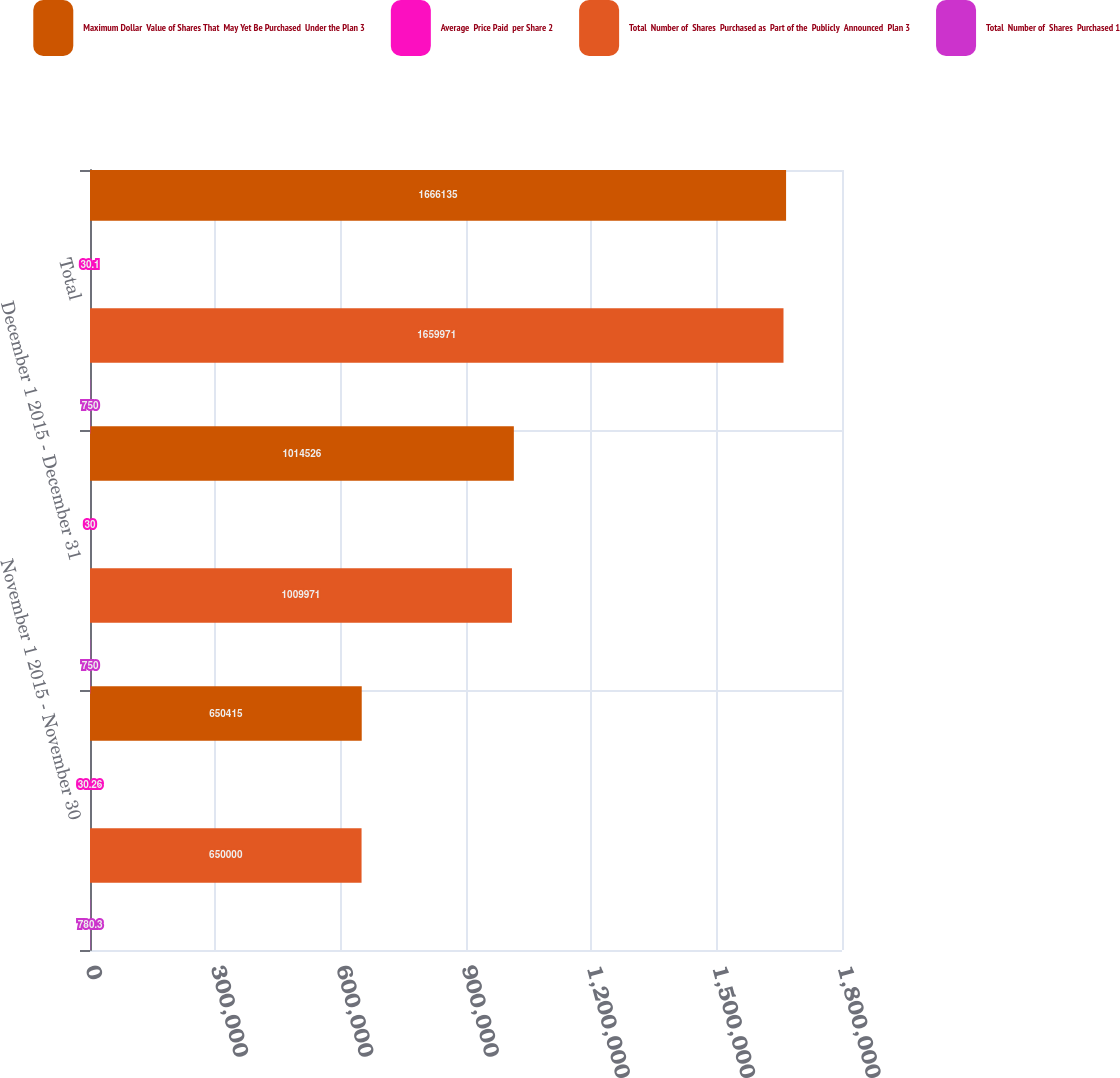Convert chart. <chart><loc_0><loc_0><loc_500><loc_500><stacked_bar_chart><ecel><fcel>November 1 2015 - November 30<fcel>December 1 2015 - December 31<fcel>Total<nl><fcel>Maximum Dollar  Value of Shares That  May Yet Be Purchased  Under the Plan 3<fcel>650415<fcel>1.01453e+06<fcel>1.66614e+06<nl><fcel>Average  Price Paid  per Share 2<fcel>30.26<fcel>30<fcel>30.1<nl><fcel>Total  Number of  Shares  Purchased as  Part of the  Publicly  Announced  Plan 3<fcel>650000<fcel>1.00997e+06<fcel>1.65997e+06<nl><fcel>Total  Number of  Shares  Purchased 1<fcel>780.3<fcel>750<fcel>750<nl></chart> 